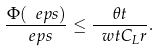Convert formula to latex. <formula><loc_0><loc_0><loc_500><loc_500>\frac { \Phi ( \ e p s ) } { \ e p s } \leq \frac { \theta t } { \ w t C _ { L } r } .</formula> 